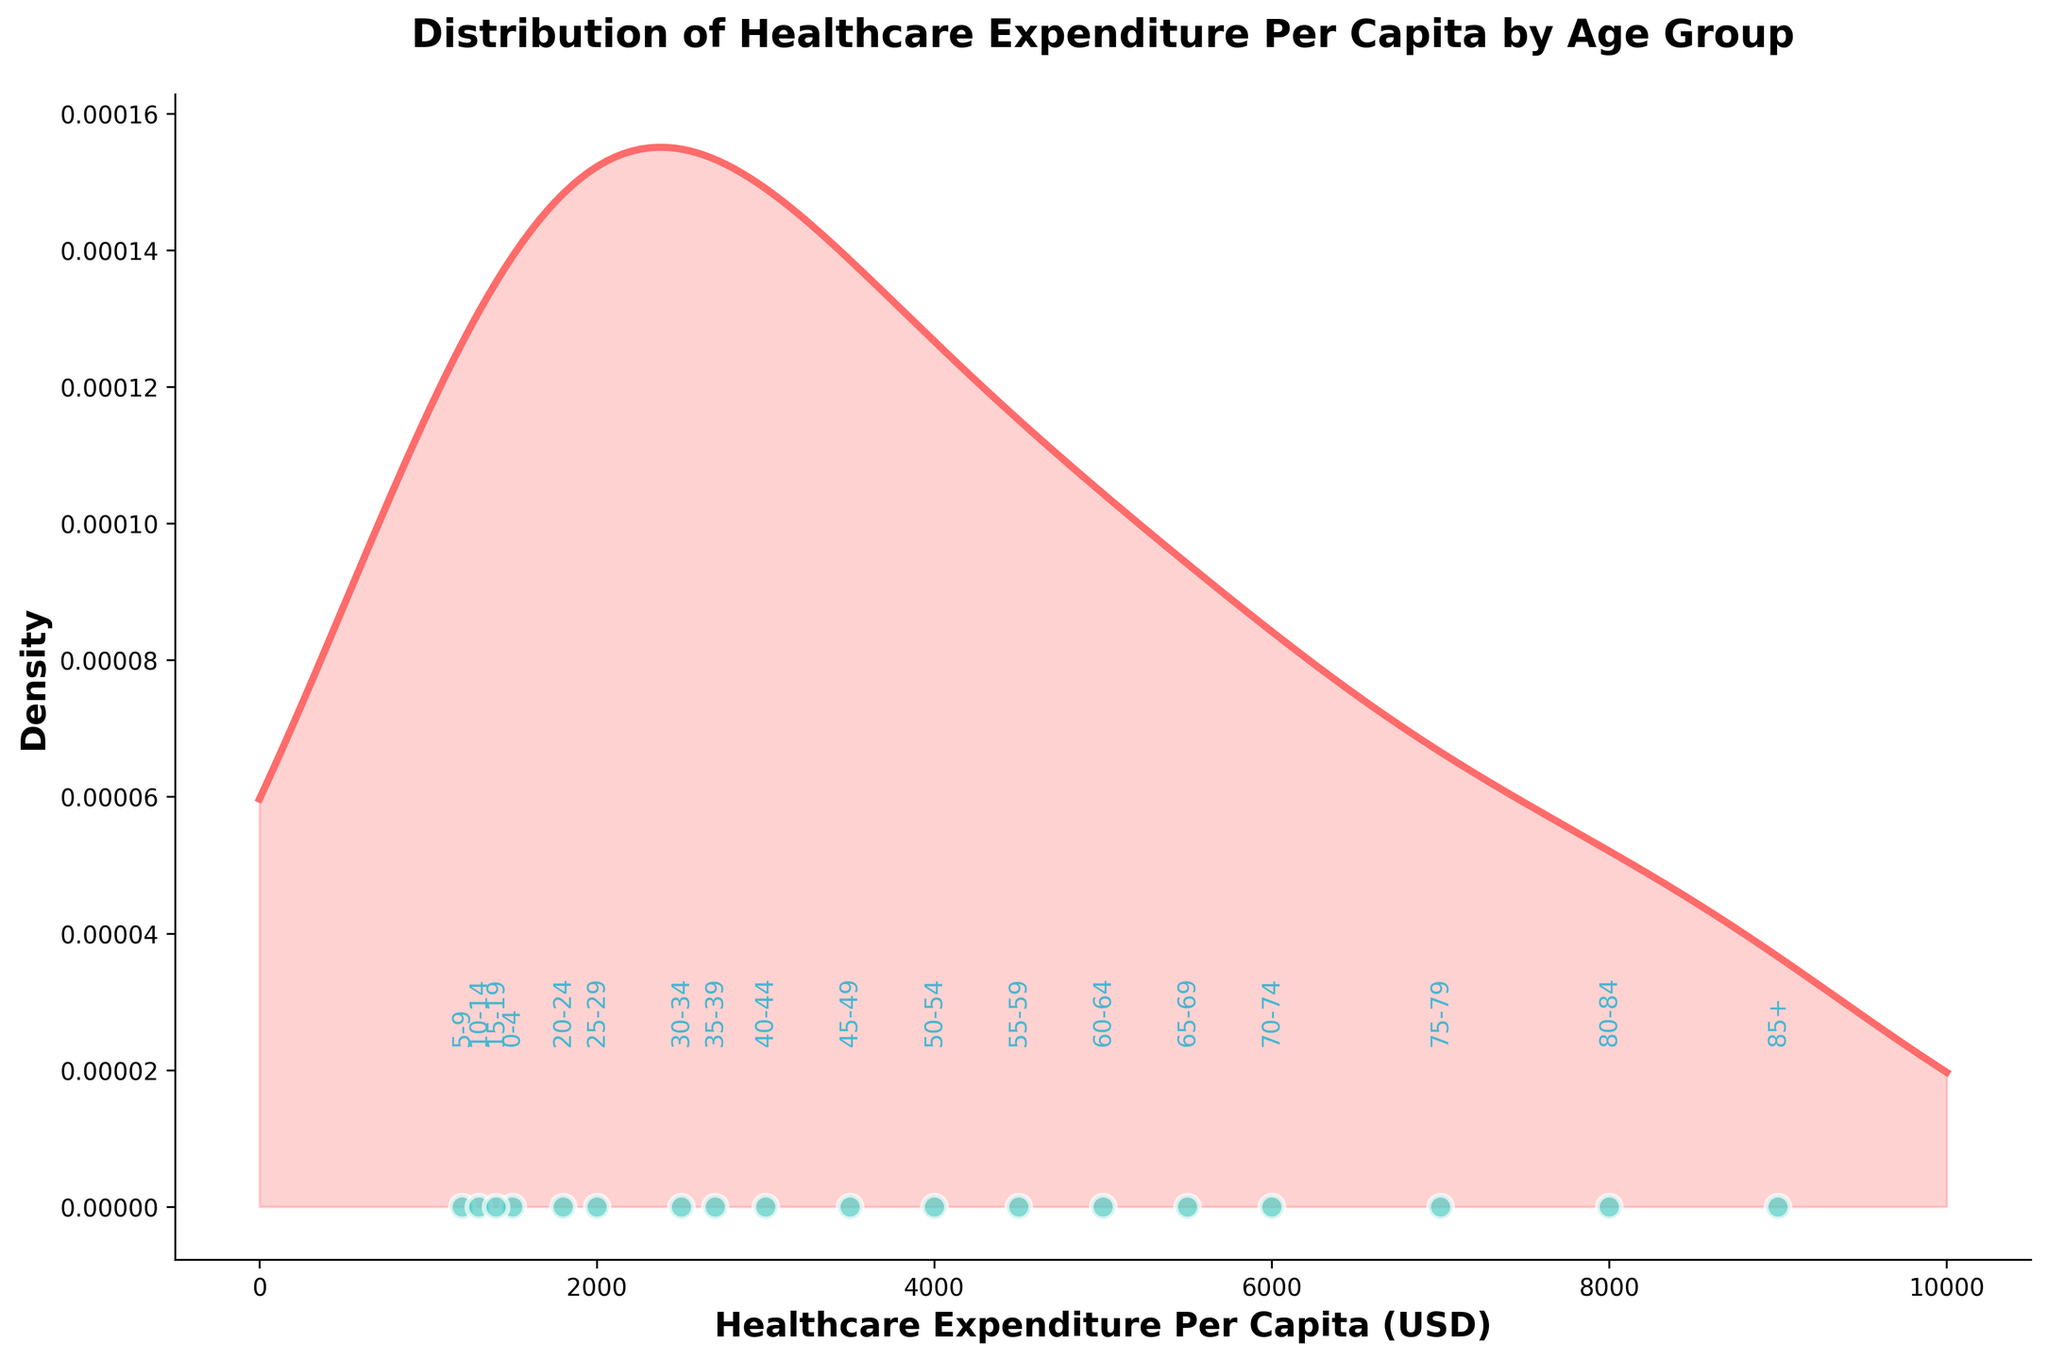What is the title of the plot? The title is usually the largest text at the top of the plot, and it describes what the plot is about.
Answer: Distribution of Healthcare Expenditure Per Capita by Age Group What is the range of healthcare expenditure per capita shown in the scatter plot? The scatter plot shows points that represent individual data values; in this case, they range from the lowest value at 1200 USD to the highest at 9000 USD.
Answer: 1200 to 9000 USD Which age group has the highest healthcare expenditure per capita? From the annotated labels on the scatter plot, the highest expenditure per capita is labeled "85+" at 9000 USD.
Answer: 85+ What is the shape of the density curve? The density curve shows the distribution of the data; it starts at a lower density, peaks, and then decreases, forming a smooth, slightly right-skewed curve.
Answer: Right-skewed How does healthcare expenditure per capita change as age increases? By following the scatter plot points from left to right (younger to older age groups), it is apparent that healthcare expenditure per capita increases as age increases.
Answer: Increases What is the approximate density value at 5000 USD expenditure? At 5000 USD, follow the vertical line up to intersect the density curve, estimate the y-axis value. The peak in density suggests around 0.00012.
Answer: 0.00012 Between which age groups does the most significant expenditure per capita increase occur? By observing the scatter points and associated labels, the biggest jump in expenditure occurs between "80-84" (8000 USD) and "85+" (9000 USD).
Answer: Between 80-84 and 85+ Are there any age groups with equal healthcare expenditure per capita? Check each pair of labeled points for age groups; every age group has a different expenditure per capita, hence no groups have equal values.
Answer: No What is the median healthcare expenditure per capita based on the scatter plot? List all expenditure values, then find the middle value. The sorted list is [1200, 1300, 1400, 1500, 1800, 2000, 2500, 2700, 3000, 3500, 4000, 4500, 5000, 5500, 6000, 7000, 8000, 9000]. The median value (middle of 18 items) is 3250 USD.
Answer: 3250 USD 